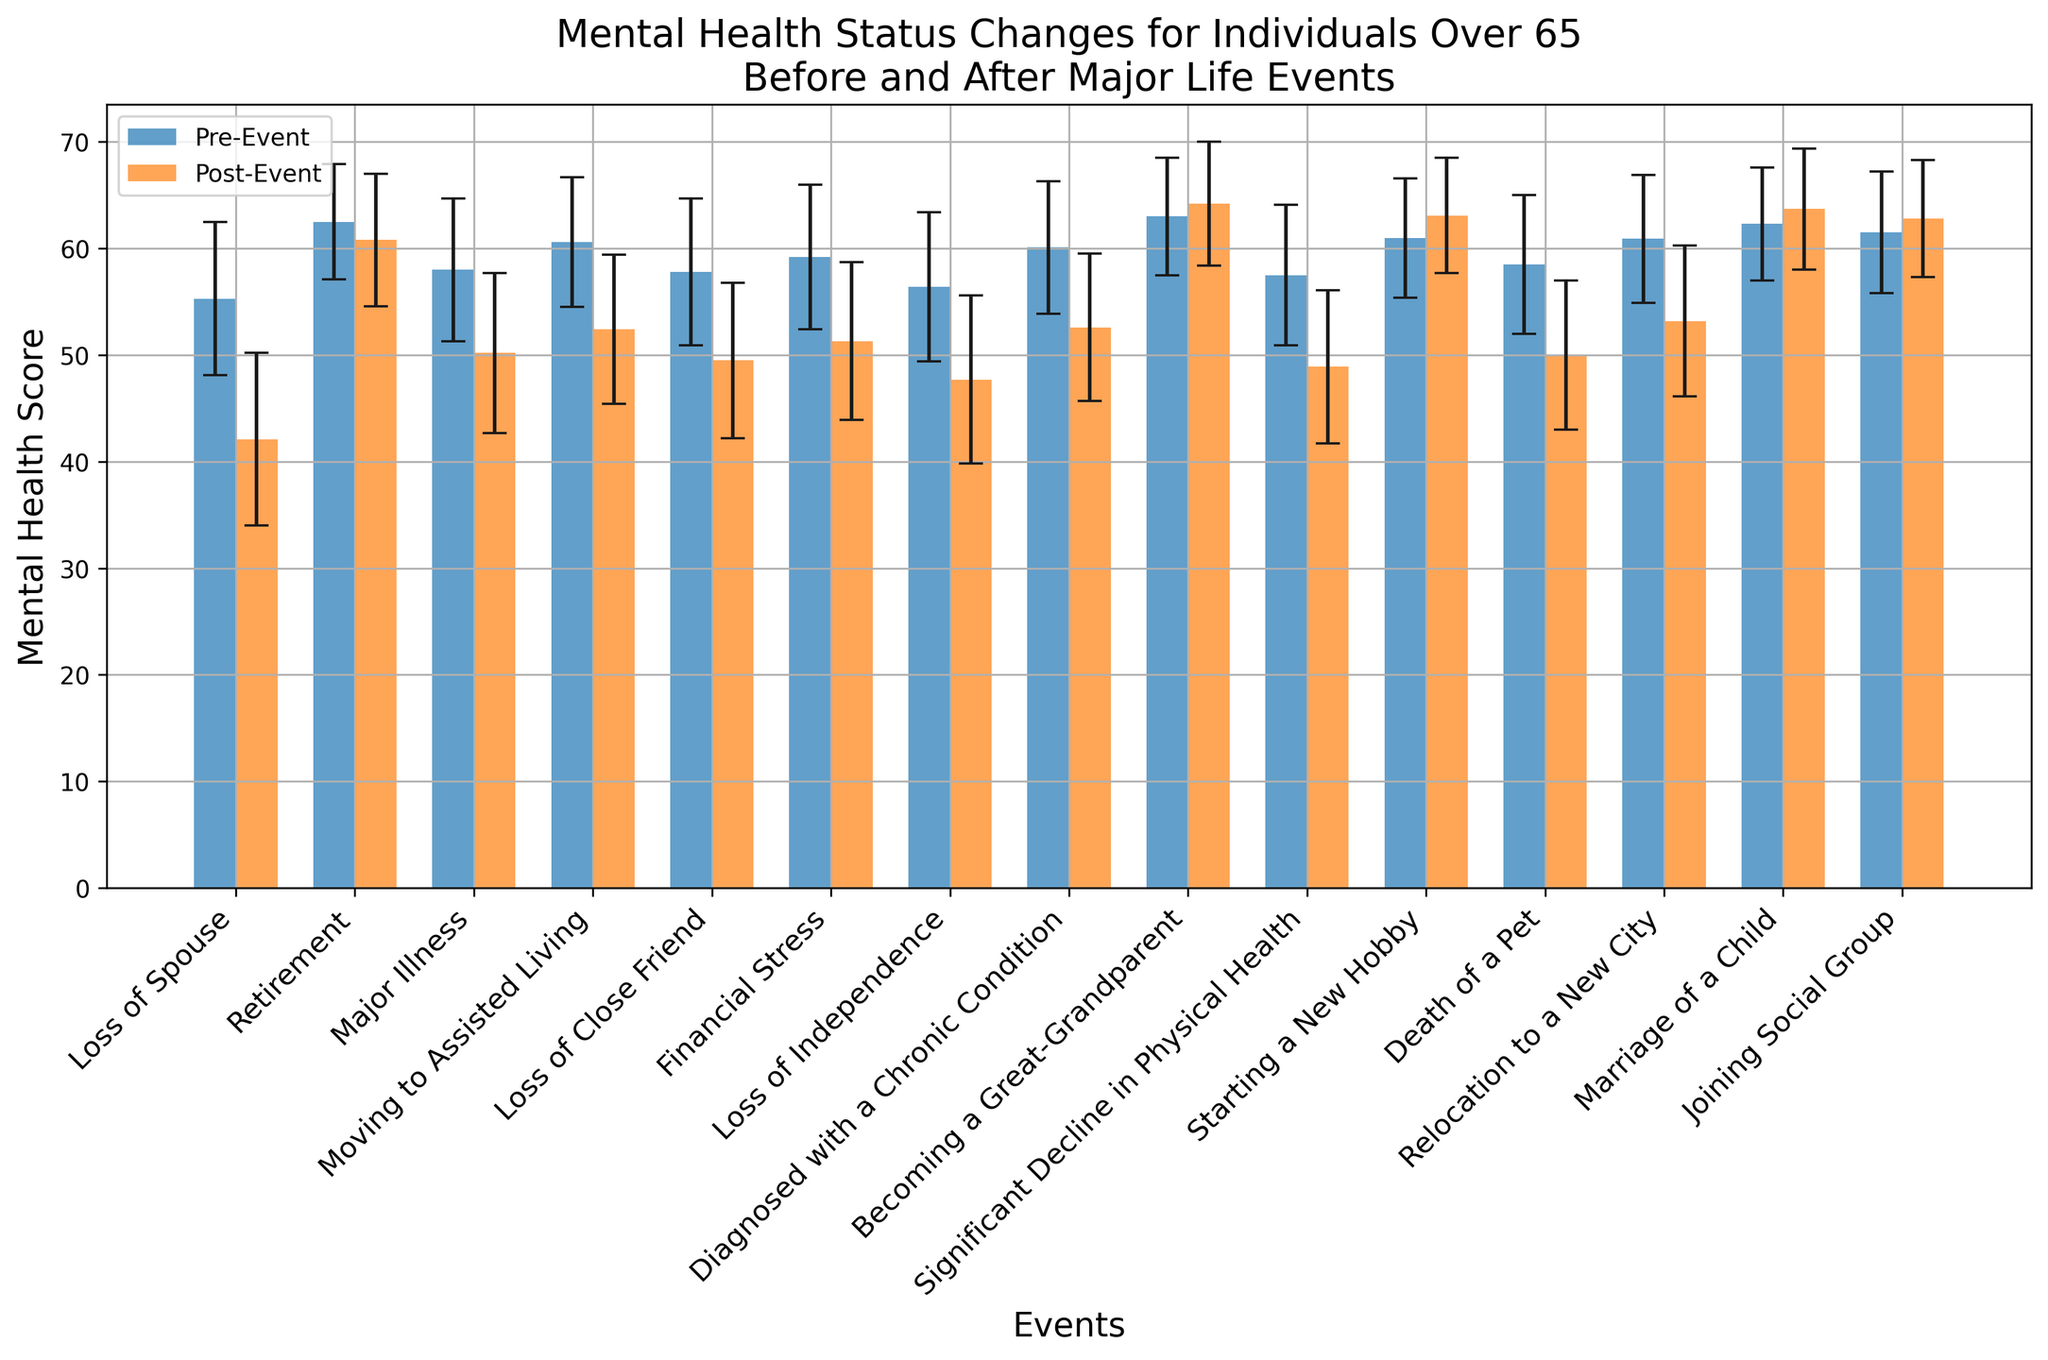What is the largest decrease in mental health score seen post-event compared to pre-event? To find the largest decrease, observe the bars for each event. For each event, subtract the post-event mental health score from the pre-event score. The largest decrease occurs for "Loss of Spouse" with a decrease from 55.3 to 42.1, which is a difference of 13.2.
Answer: 13.2 Which event shows an improvement in mental health score post-event compared to pre-event? To determine improvement, compare the pre-event and post-event scores and look for any events where the post-event score is higher than the pre-event score. The events "Becoming a Great-Grandparent" and "Starting a New Hobby" show improvements (63.0 to 64.2 and 61.0 to 63.1 respectively).
Answer: Becoming a Great-Grandparent, Starting a New Hobby Which event had the highest pre-event mental health score? Review the height of the bars before the event for all events and find the tallest one. The event "Becoming a Great-Grandparent" had the highest pre-event mental health score at 63.0.
Answer: Becoming a Great-Grandparent What is the combined mental health score post-event for "Loss of Spouse" and "Major Illness"? Add the post-event scores for both events: "Loss of Spouse" (42.1) and "Major Illness" (50.2). The combined score is 42.1 + 50.2 = 92.3.
Answer: 92.3 Which event has the smallest change in mental health score before and after the event? Calculate the absolute difference between pre-event and post-event scores for each event and identify the smallest value. "Retirement" has the smallest change with a difference of 62.5 - 60.8 = 1.7.
Answer: Retirement How many events have a post-event mental health score of 50 or lower? Identify the events where the post-event mental health scores are 50 or below. The relevant events are "Loss of Spouse" (42.1), "Major Illness" (50.2), "Loss of Close Friend" (49.5), and "Death of a Pet" (50.0). This makes 4 events.
Answer: 4 Which event has both relatively low standard deviations before and after the event? Compare the standard deviations for both pre-event and post-event for each event. Look for events with smaller standard deviations. "Marriage of a Child" has standard deviations of 5.3 and 5.7 for pre-event and post-event, respectively, which are relatively low.
Answer: Marriage of a Child For the event "Loss of Spouse," what is the difference between the pre-event and post-event standard deviations? Subtract the pre-event standard deviation from the post-event standard deviation for "Loss of Spouse": 8.1 - 7.2 = 0.9.
Answer: 0.9 For the events "Joining Social Group" and "Retirement," which had a higher post-event mental health score? Compare the post-event mental health scores of "Joining Social Group" (62.8) and "Retirement" (60.8) directly. "Joining Social Group" has a higher score.
Answer: Joining Social Group 